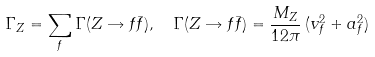<formula> <loc_0><loc_0><loc_500><loc_500>\Gamma _ { Z } & = \sum _ { f } \Gamma ( Z \rightarrow f \bar { f } ) , \quad \Gamma ( Z \rightarrow f \bar { f } ) = \frac { M _ { Z } } { 1 2 \pi } \, ( v _ { f } ^ { 2 } + a _ { f } ^ { 2 } )</formula> 